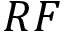<formula> <loc_0><loc_0><loc_500><loc_500>R F</formula> 